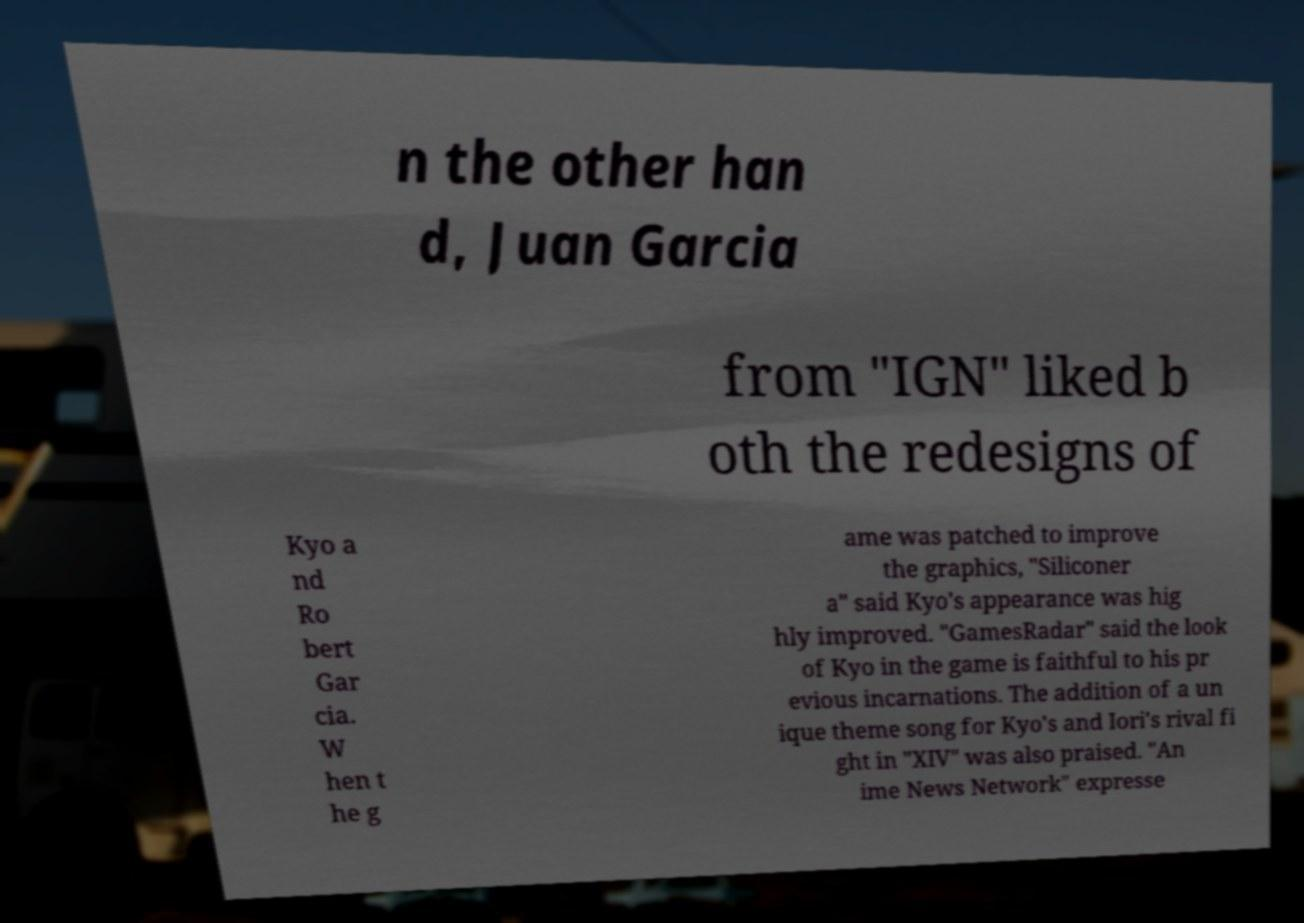Please identify and transcribe the text found in this image. n the other han d, Juan Garcia from "IGN" liked b oth the redesigns of Kyo a nd Ro bert Gar cia. W hen t he g ame was patched to improve the graphics, "Siliconer a" said Kyo's appearance was hig hly improved. "GamesRadar" said the look of Kyo in the game is faithful to his pr evious incarnations. The addition of a un ique theme song for Kyo's and Iori's rival fi ght in "XIV" was also praised. "An ime News Network" expresse 